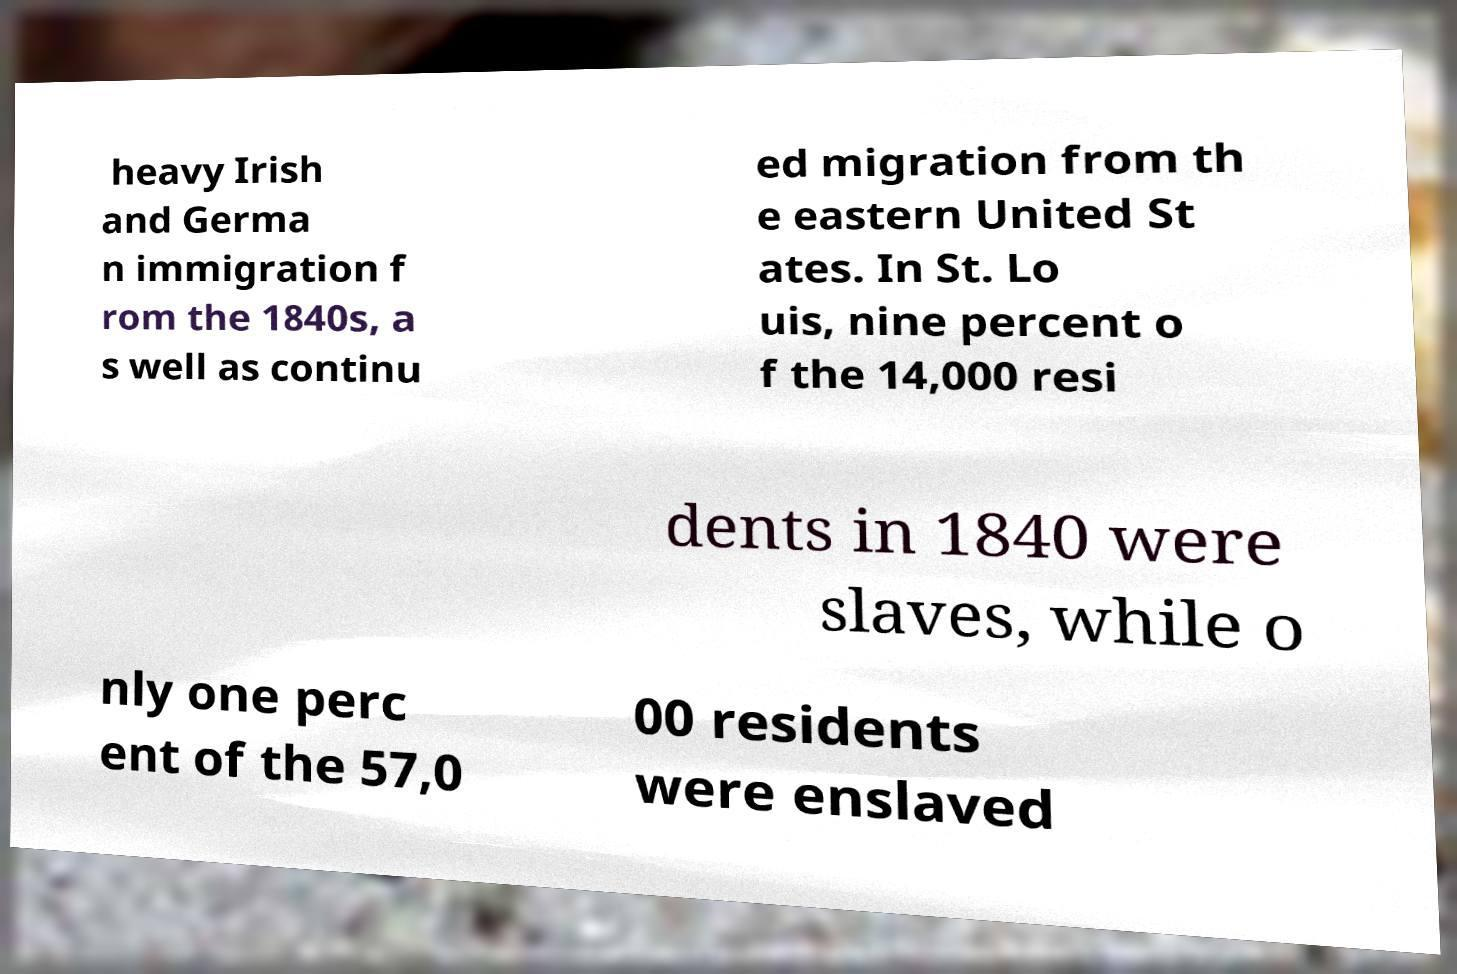There's text embedded in this image that I need extracted. Can you transcribe it verbatim? heavy Irish and Germa n immigration f rom the 1840s, a s well as continu ed migration from th e eastern United St ates. In St. Lo uis, nine percent o f the 14,000 resi dents in 1840 were slaves, while o nly one perc ent of the 57,0 00 residents were enslaved 